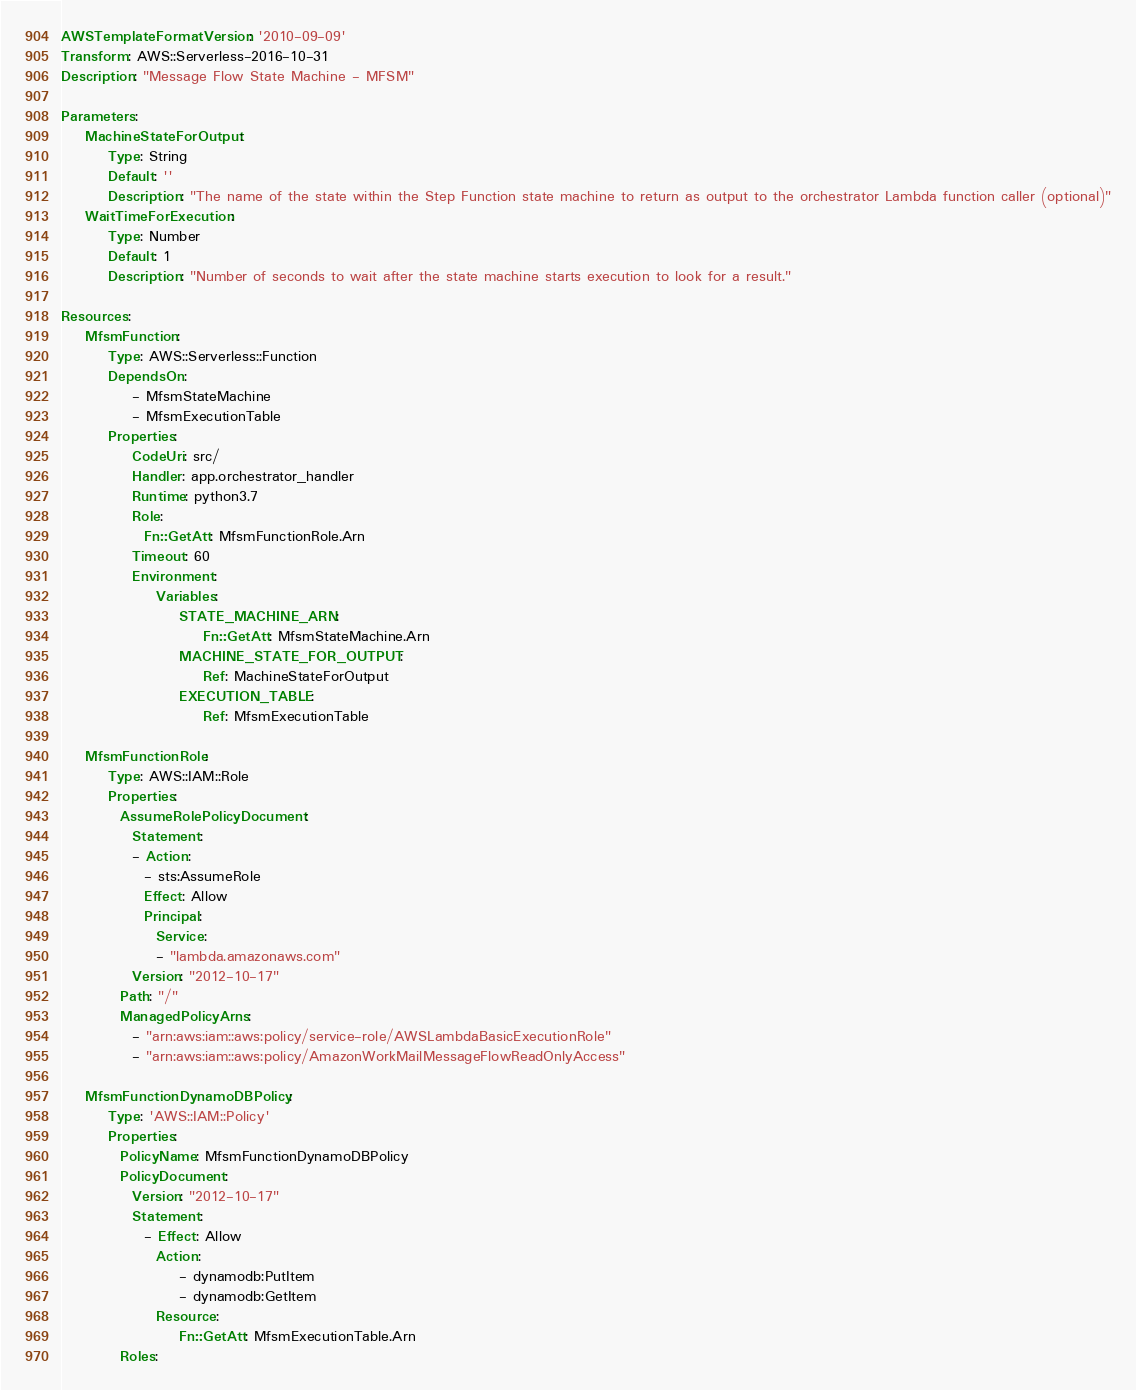Convert code to text. <code><loc_0><loc_0><loc_500><loc_500><_YAML_>AWSTemplateFormatVersion: '2010-09-09'
Transform: AWS::Serverless-2016-10-31
Description: "Message Flow State Machine - MFSM"

Parameters:
    MachineStateForOutput:
        Type: String
        Default: ''
        Description: "The name of the state within the Step Function state machine to return as output to the orchestrator Lambda function caller (optional)"
    WaitTimeForExecution:
        Type: Number
        Default: 1
        Description: "Number of seconds to wait after the state machine starts execution to look for a result."

Resources:
    MfsmFunction:
        Type: AWS::Serverless::Function 
        DependsOn: 
            - MfsmStateMachine
            - MfsmExecutionTable
        Properties:
            CodeUri: src/
            Handler: app.orchestrator_handler
            Runtime: python3.7
            Role:
              Fn::GetAtt: MfsmFunctionRole.Arn
            Timeout: 60
            Environment:
                Variables:
                    STATE_MACHINE_ARN:
                        Fn::GetAtt: MfsmStateMachine.Arn
                    MACHINE_STATE_FOR_OUTPUT:
                        Ref: MachineStateForOutput
                    EXECUTION_TABLE:
                        Ref: MfsmExecutionTable

    MfsmFunctionRole:
        Type: AWS::IAM::Role
        Properties:
          AssumeRolePolicyDocument:
            Statement:
            - Action:
              - sts:AssumeRole
              Effect: Allow
              Principal:
                Service:
                - "lambda.amazonaws.com"
            Version: "2012-10-17"
          Path: "/"
          ManagedPolicyArns:
            - "arn:aws:iam::aws:policy/service-role/AWSLambdaBasicExecutionRole"
            - "arn:aws:iam::aws:policy/AmazonWorkMailMessageFlowReadOnlyAccess"

    MfsmFunctionDynamoDBPolicy:
        Type: 'AWS::IAM::Policy'
        Properties:
          PolicyName: MfsmFunctionDynamoDBPolicy
          PolicyDocument:
            Version: "2012-10-17"
            Statement:
              - Effect: Allow
                Action:
                    - dynamodb:PutItem
                    - dynamodb:GetItem
                Resource:
                    Fn::GetAtt: MfsmExecutionTable.Arn
          Roles:</code> 